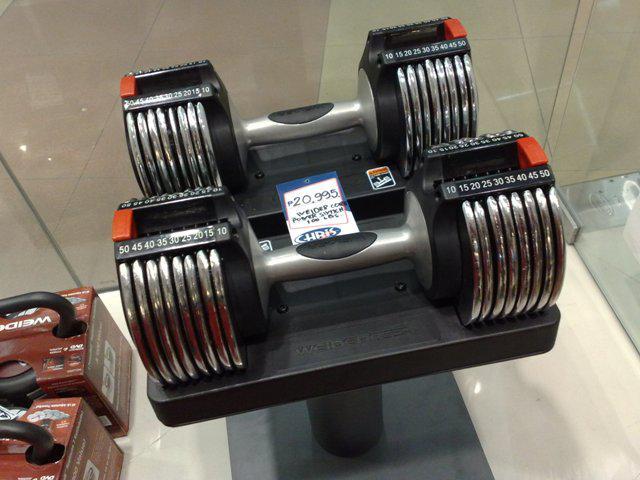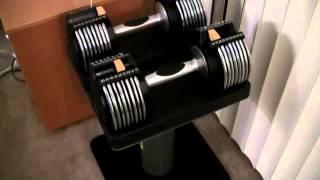The first image is the image on the left, the second image is the image on the right. For the images shown, is this caption "Each image includes one pair of dumbbell bars with weights, and at least one image shows the dumbbells on a stand with a square base." true? Answer yes or no. Yes. The first image is the image on the left, the second image is the image on the right. For the images displayed, is the sentence "The left and right image contains the same number of weights sitting on a tower." factually correct? Answer yes or no. Yes. 